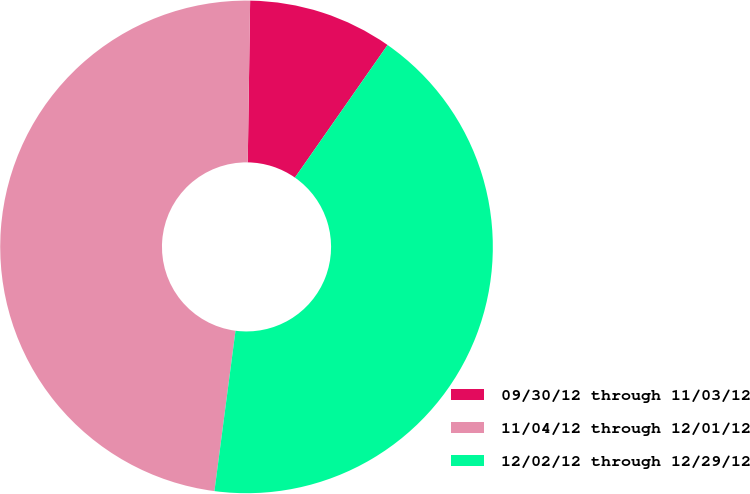Convert chart to OTSL. <chart><loc_0><loc_0><loc_500><loc_500><pie_chart><fcel>09/30/12 through 11/03/12<fcel>11/04/12 through 12/01/12<fcel>12/02/12 through 12/29/12<nl><fcel>9.47%<fcel>48.15%<fcel>42.37%<nl></chart> 